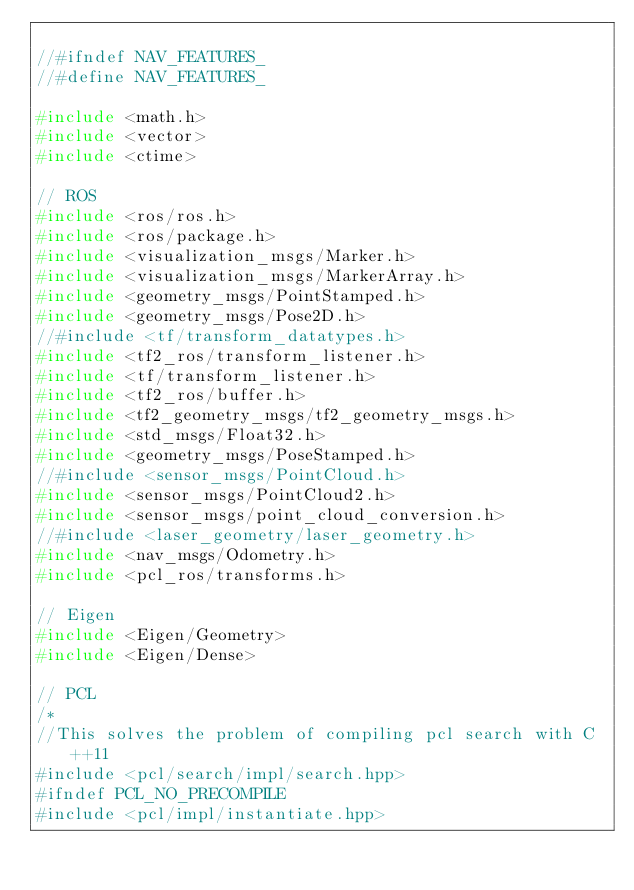Convert code to text. <code><loc_0><loc_0><loc_500><loc_500><_C_>
//#ifndef NAV_FEATURES_
//#define NAV_FEATURES_

#include <math.h>
#include <vector>
#include <ctime>

// ROS
#include <ros/ros.h>
#include <ros/package.h>
#include <visualization_msgs/Marker.h>
#include <visualization_msgs/MarkerArray.h>
#include <geometry_msgs/PointStamped.h>
#include <geometry_msgs/Pose2D.h>
//#include <tf/transform_datatypes.h>
#include <tf2_ros/transform_listener.h>
#include <tf/transform_listener.h>
#include <tf2_ros/buffer.h>
#include <tf2_geometry_msgs/tf2_geometry_msgs.h>
#include <std_msgs/Float32.h>
#include <geometry_msgs/PoseStamped.h>
//#include <sensor_msgs/PointCloud.h>
#include <sensor_msgs/PointCloud2.h>
#include <sensor_msgs/point_cloud_conversion.h>
//#include <laser_geometry/laser_geometry.h>
#include <nav_msgs/Odometry.h>
#include <pcl_ros/transforms.h>

// Eigen
#include <Eigen/Geometry>
#include <Eigen/Dense>

// PCL
/*
//This solves the problem of compiling pcl search with C++11
#include <pcl/search/impl/search.hpp>
#ifndef PCL_NO_PRECOMPILE
#include <pcl/impl/instantiate.hpp></code> 